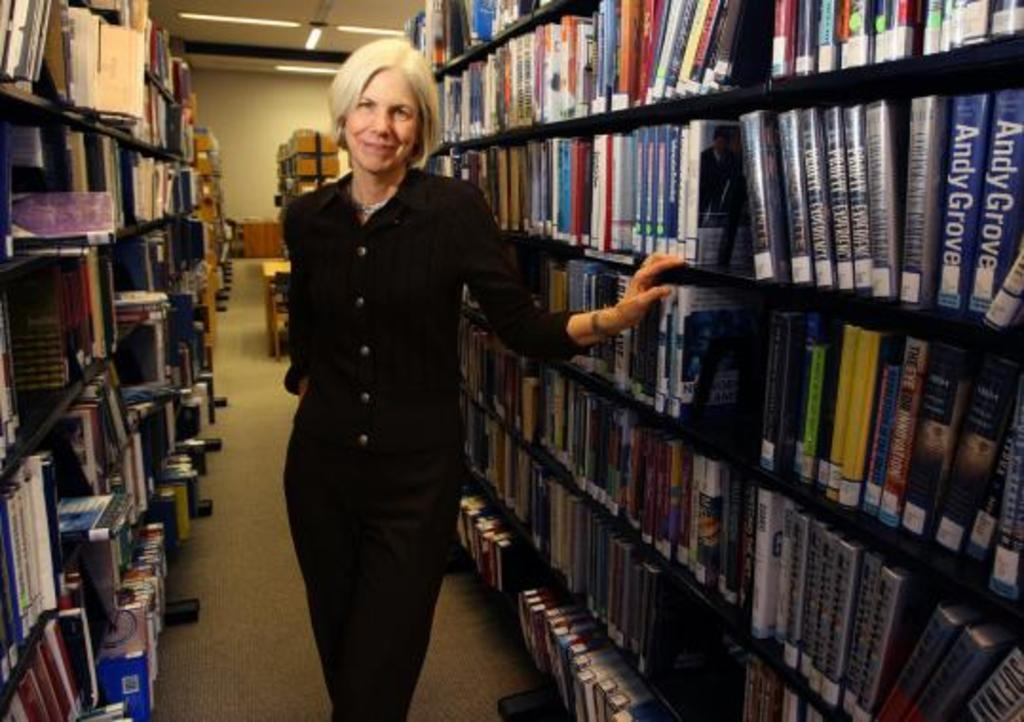Provide a one-sentence caption for the provided image. a woman with a library of books, one book says Andy Grove. 